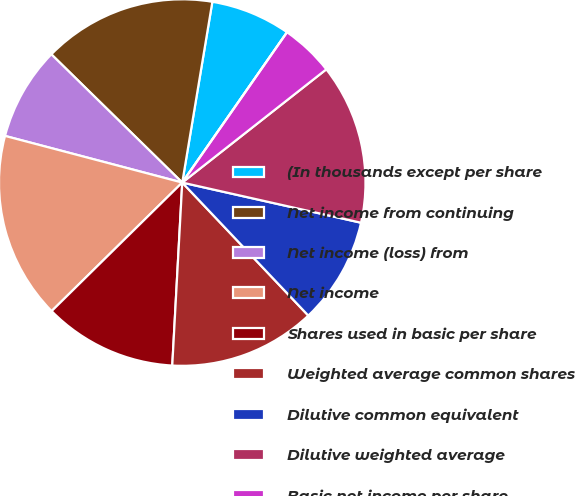Convert chart. <chart><loc_0><loc_0><loc_500><loc_500><pie_chart><fcel>(In thousands except per share<fcel>Net income from continuing<fcel>Net income (loss) from<fcel>Net income<fcel>Shares used in basic per share<fcel>Weighted average common shares<fcel>Dilutive common equivalent<fcel>Dilutive weighted average<fcel>Basic net income per share<fcel>Basic net income (loss) per<nl><fcel>7.06%<fcel>15.29%<fcel>8.24%<fcel>16.47%<fcel>11.76%<fcel>12.94%<fcel>9.41%<fcel>14.12%<fcel>4.71%<fcel>0.0%<nl></chart> 